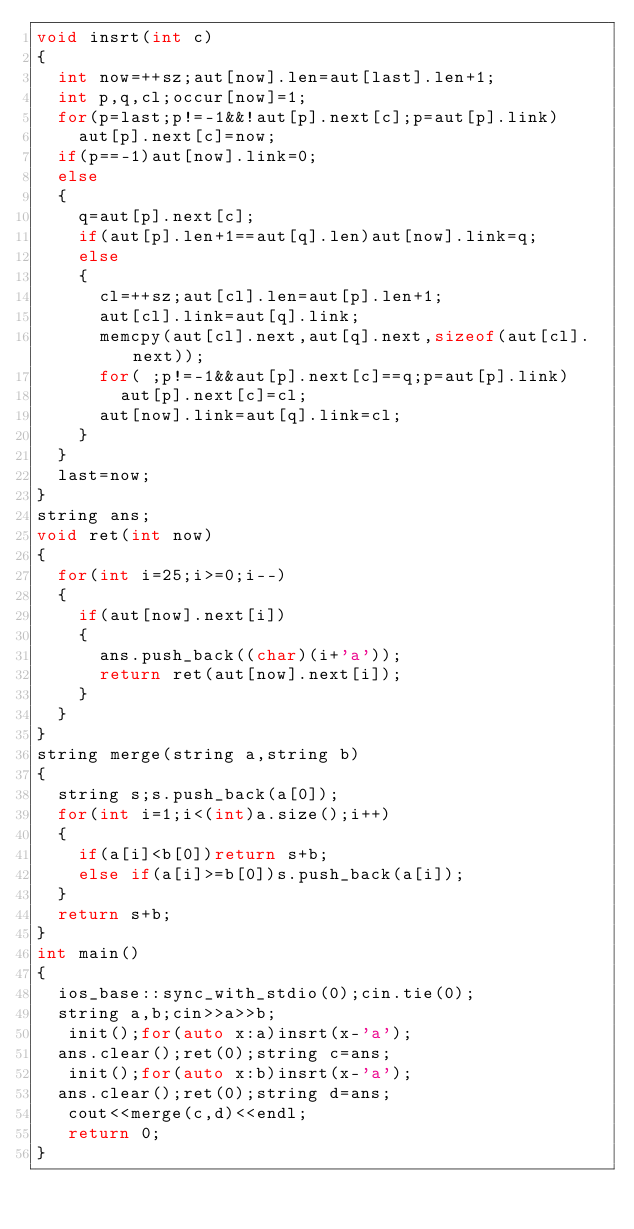<code> <loc_0><loc_0><loc_500><loc_500><_C++_>void insrt(int c)
{
  int now=++sz;aut[now].len=aut[last].len+1;
  int p,q,cl;occur[now]=1;
  for(p=last;p!=-1&&!aut[p].next[c];p=aut[p].link)
    aut[p].next[c]=now;
  if(p==-1)aut[now].link=0;
  else
  {
    q=aut[p].next[c];
    if(aut[p].len+1==aut[q].len)aut[now].link=q;
    else
    {
      cl=++sz;aut[cl].len=aut[p].len+1;
      aut[cl].link=aut[q].link;
      memcpy(aut[cl].next,aut[q].next,sizeof(aut[cl].next));
      for( ;p!=-1&&aut[p].next[c]==q;p=aut[p].link)
        aut[p].next[c]=cl;
      aut[now].link=aut[q].link=cl;
    }
  }
  last=now;
}
string ans;
void ret(int now)
{
  for(int i=25;i>=0;i--)
  {
    if(aut[now].next[i])
    {
      ans.push_back((char)(i+'a'));
      return ret(aut[now].next[i]);
    }
  }
}
string merge(string a,string b)
{
  string s;s.push_back(a[0]);
  for(int i=1;i<(int)a.size();i++)
  {
    if(a[i]<b[0])return s+b;
    else if(a[i]>=b[0])s.push_back(a[i]);
  }
  return s+b;
}
int main()
{
  ios_base::sync_with_stdio(0);cin.tie(0);
  string a,b;cin>>a>>b;
   init();for(auto x:a)insrt(x-'a');
  ans.clear();ret(0);string c=ans;
   init();for(auto x:b)insrt(x-'a');
  ans.clear();ret(0);string d=ans;
   cout<<merge(c,d)<<endl;
   return 0;
}</code> 